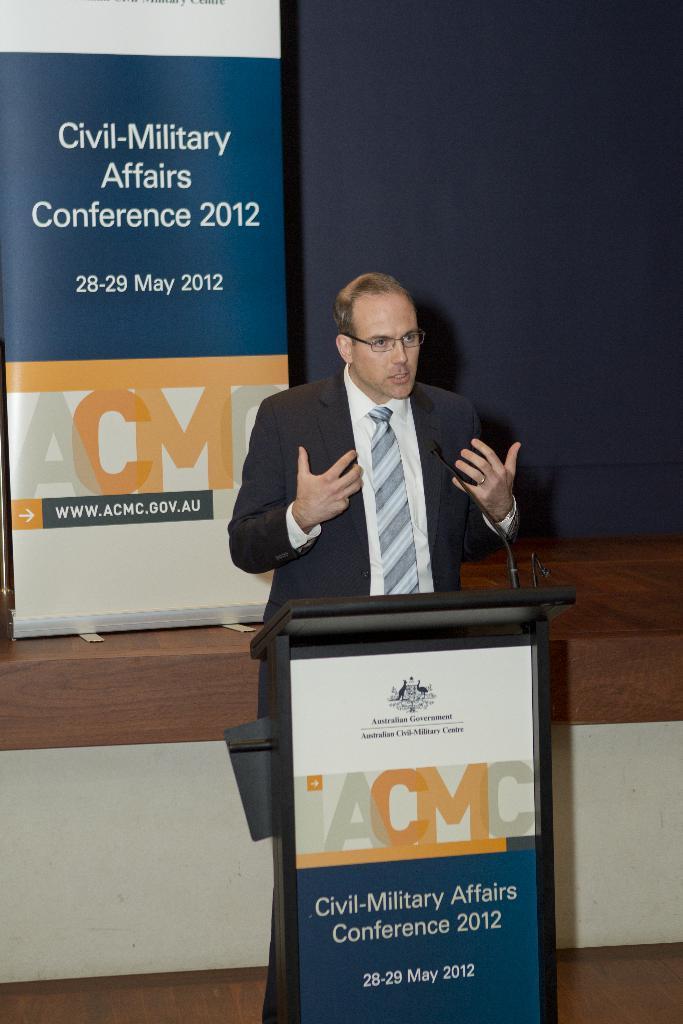Describe this image in one or two sentences. In the center of the image we can see a man standing, before him there is a podium and we can see a mic placed on the podium. In the background there is a wall and we can see a banner. 